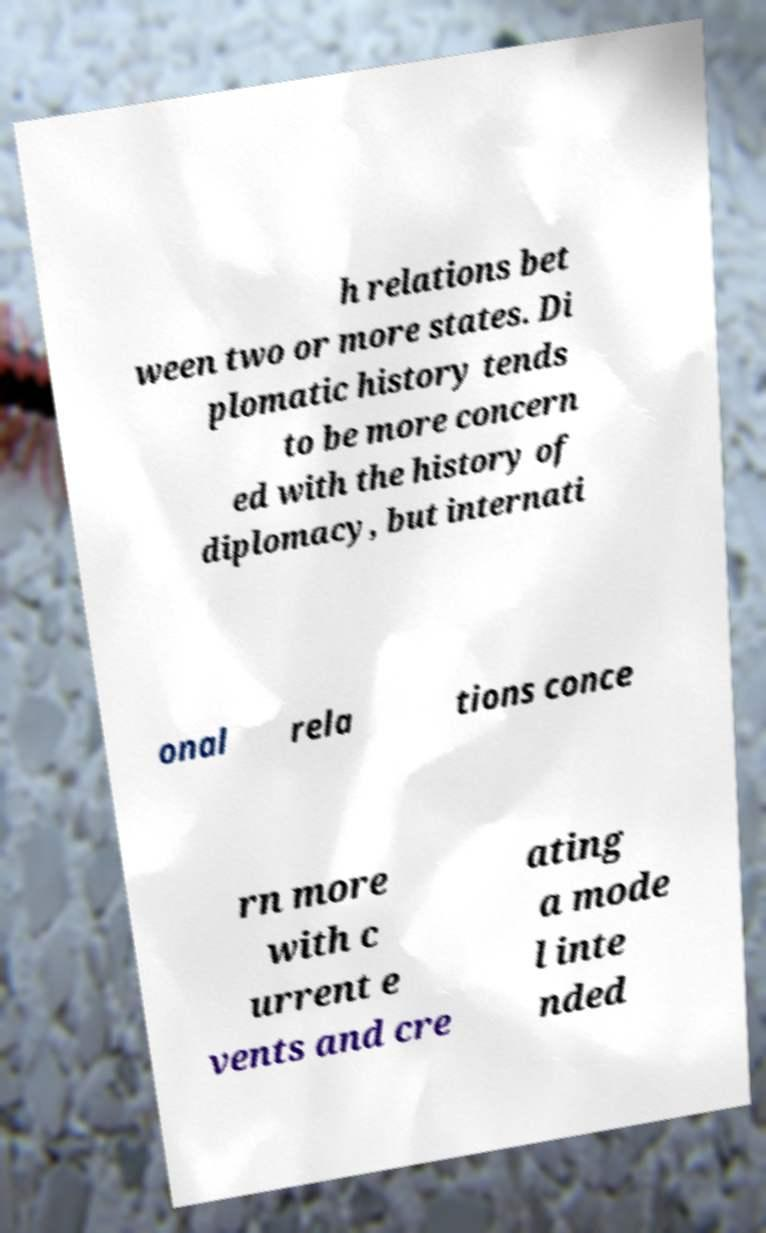For documentation purposes, I need the text within this image transcribed. Could you provide that? h relations bet ween two or more states. Di plomatic history tends to be more concern ed with the history of diplomacy, but internati onal rela tions conce rn more with c urrent e vents and cre ating a mode l inte nded 